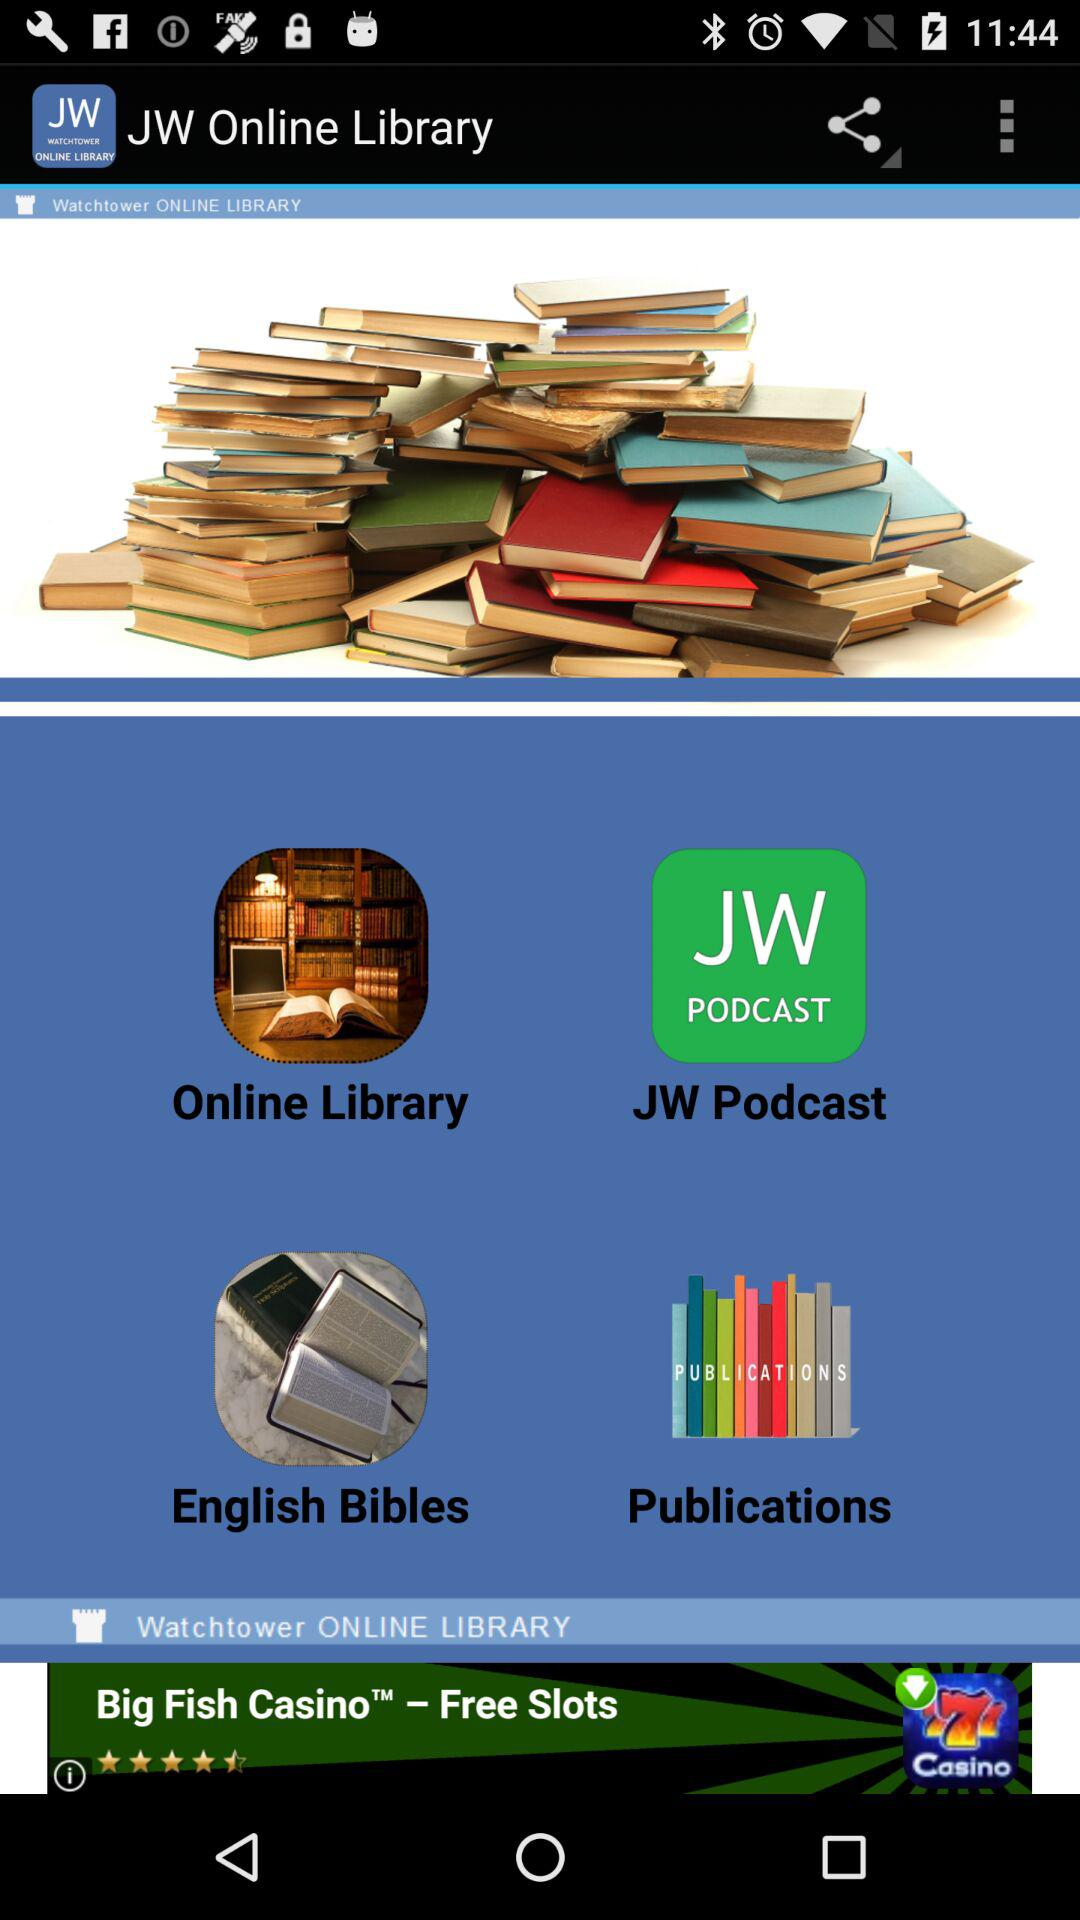What is the app name? The app name is "JW Online Library". 